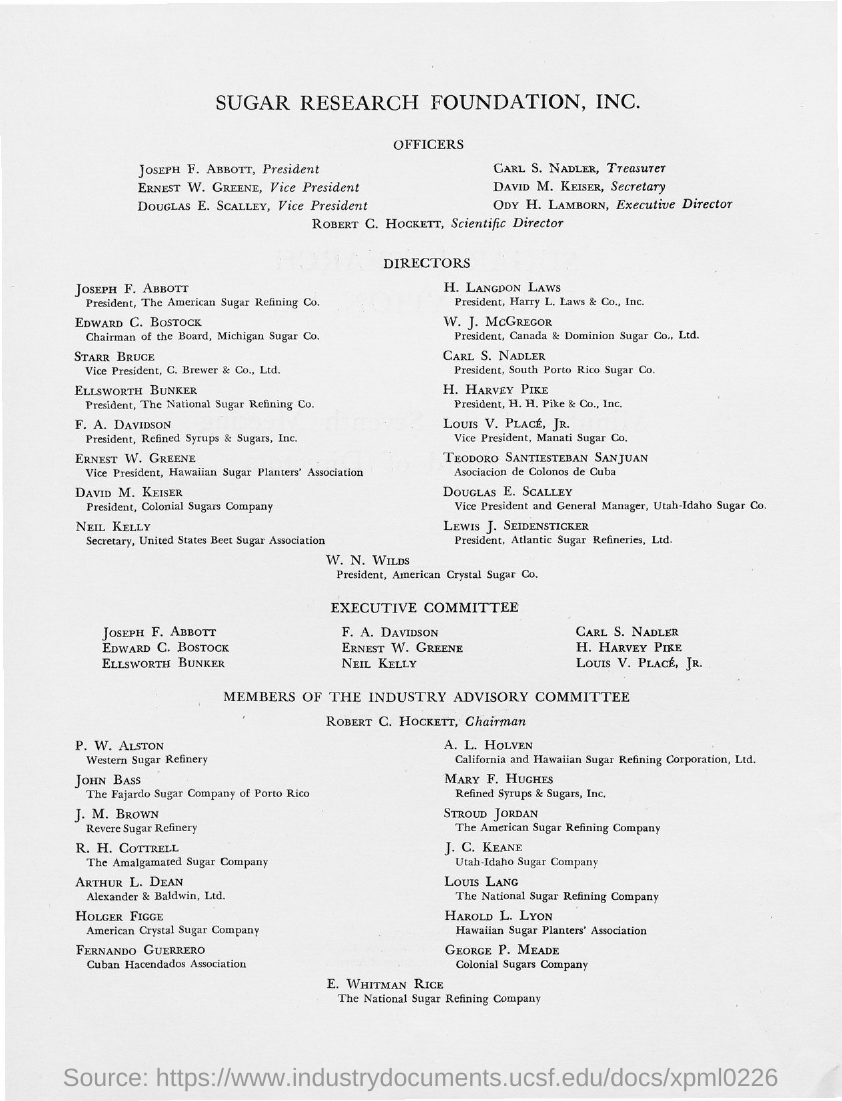What is the position of carl s. nadler ?
Provide a short and direct response. TREASURER. What is the position of david m. keiser?
Your response must be concise. SECRETARY. What is the position of ody h. lamborn?
Make the answer very short. EXECUTIVE DIRECTOR. What is the position of robert c. hockett ?
Ensure brevity in your answer.  Scientific Director. 